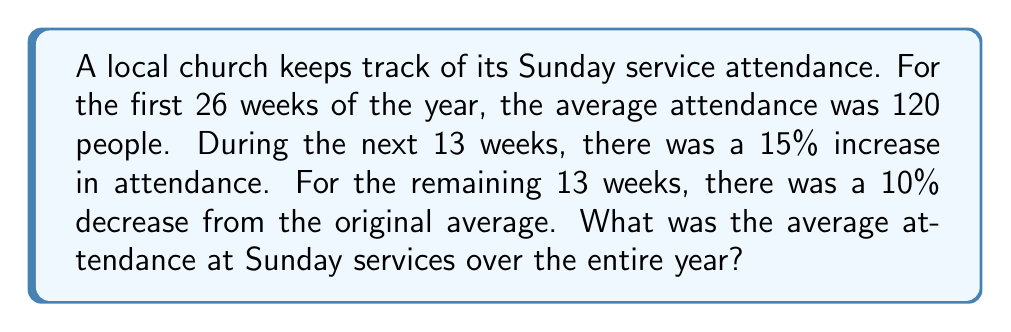Can you solve this math problem? Let's approach this step-by-step:

1) First, let's calculate the attendance for each period:

   a) First 26 weeks: 120 people on average
   b) Next 13 weeks: 120 * 1.15 = 138 people on average (15% increase)
   c) Last 13 weeks: 120 * 0.90 = 108 people on average (10% decrease)

2) Now, let's calculate the total attendance for each period:

   a) First 26 weeks: 26 * 120 = 3120 people
   b) Next 13 weeks: 13 * 138 = 1794 people
   c) Last 13 weeks: 13 * 108 = 1404 people

3) Let's sum up the total attendance for the year:

   $$ \text{Total attendance} = 3120 + 1794 + 1404 = 6318 \text{ people} $$

4) To find the average, we divide the total attendance by the number of weeks in a year:

   $$ \text{Average attendance} = \frac{6318}{52} = 121.5 \text{ people} $$

Therefore, the average attendance at Sunday services over the entire year was 121.5 people.
Answer: 121.5 people 